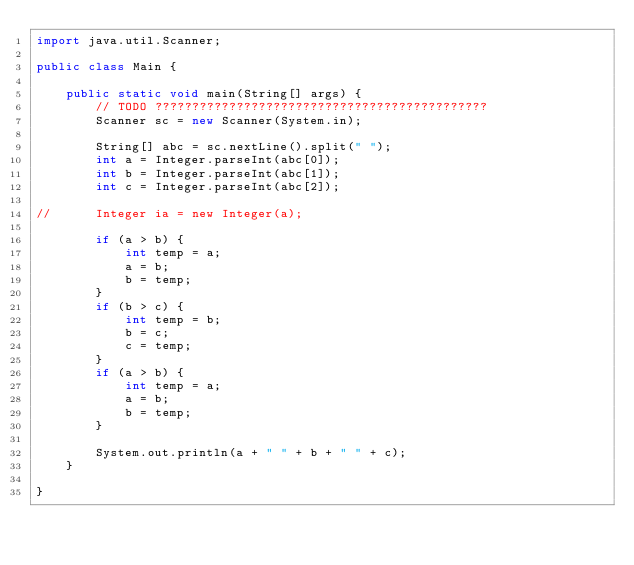Convert code to text. <code><loc_0><loc_0><loc_500><loc_500><_Java_>import java.util.Scanner;

public class Main {

	public static void main(String[] args) {
		// TODO ?????????????????????????????????????????????
		Scanner sc = new Scanner(System.in);

		String[] abc = sc.nextLine().split(" ");
		int a = Integer.parseInt(abc[0]);
		int b = Integer.parseInt(abc[1]);
		int c = Integer.parseInt(abc[2]);

//		Integer ia = new Integer(a);

		if (a > b) {
			int temp = a;
			a = b;
			b = temp;
		}
		if (b > c) {
			int temp = b;
			b = c;
			c = temp;
		}
		if (a > b) {
			int temp = a;
			a = b;
			b = temp;
		}

		System.out.println(a + " " + b + " " + c);
	}

}</code> 